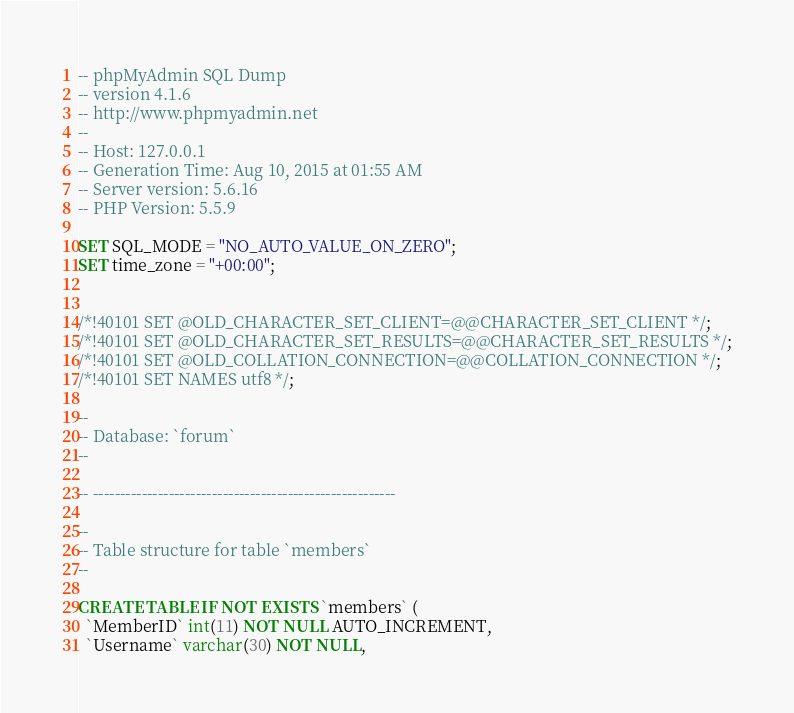<code> <loc_0><loc_0><loc_500><loc_500><_SQL_>-- phpMyAdmin SQL Dump
-- version 4.1.6
-- http://www.phpmyadmin.net
--
-- Host: 127.0.0.1
-- Generation Time: Aug 10, 2015 at 01:55 AM
-- Server version: 5.6.16
-- PHP Version: 5.5.9

SET SQL_MODE = "NO_AUTO_VALUE_ON_ZERO";
SET time_zone = "+00:00";


/*!40101 SET @OLD_CHARACTER_SET_CLIENT=@@CHARACTER_SET_CLIENT */;
/*!40101 SET @OLD_CHARACTER_SET_RESULTS=@@CHARACTER_SET_RESULTS */;
/*!40101 SET @OLD_COLLATION_CONNECTION=@@COLLATION_CONNECTION */;
/*!40101 SET NAMES utf8 */;

--
-- Database: `forum`
--

-- --------------------------------------------------------

--
-- Table structure for table `members`
--

CREATE TABLE IF NOT EXISTS `members` (
  `MemberID` int(11) NOT NULL AUTO_INCREMENT,
  `Username` varchar(30) NOT NULL,</code> 